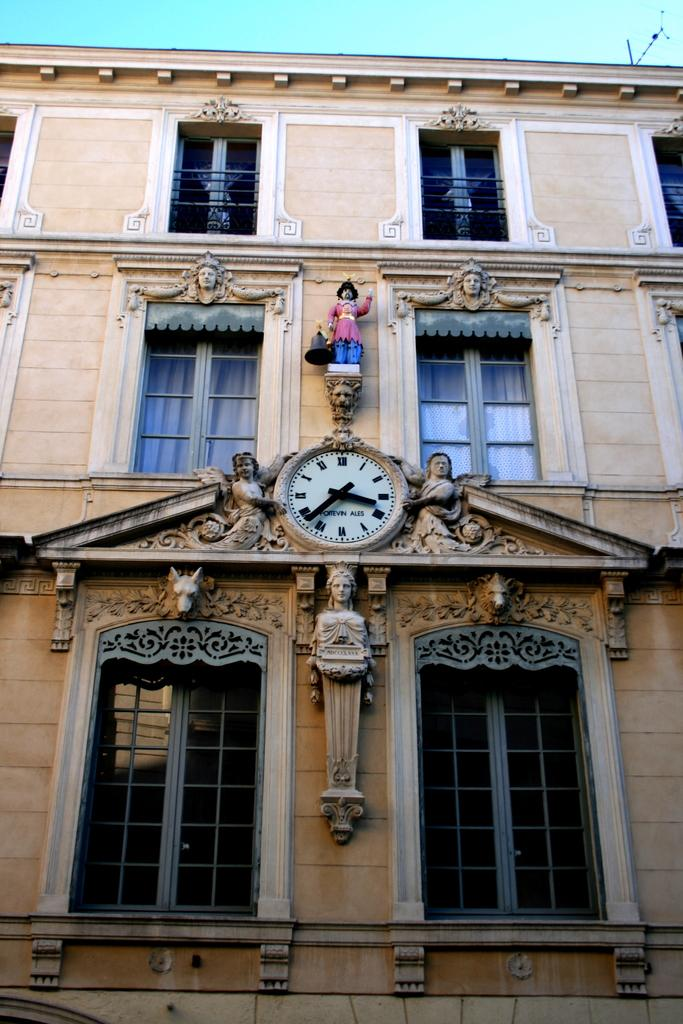<image>
Describe the image concisely. The outside of a brown building with a statue and clock from Foitevin Ales. 